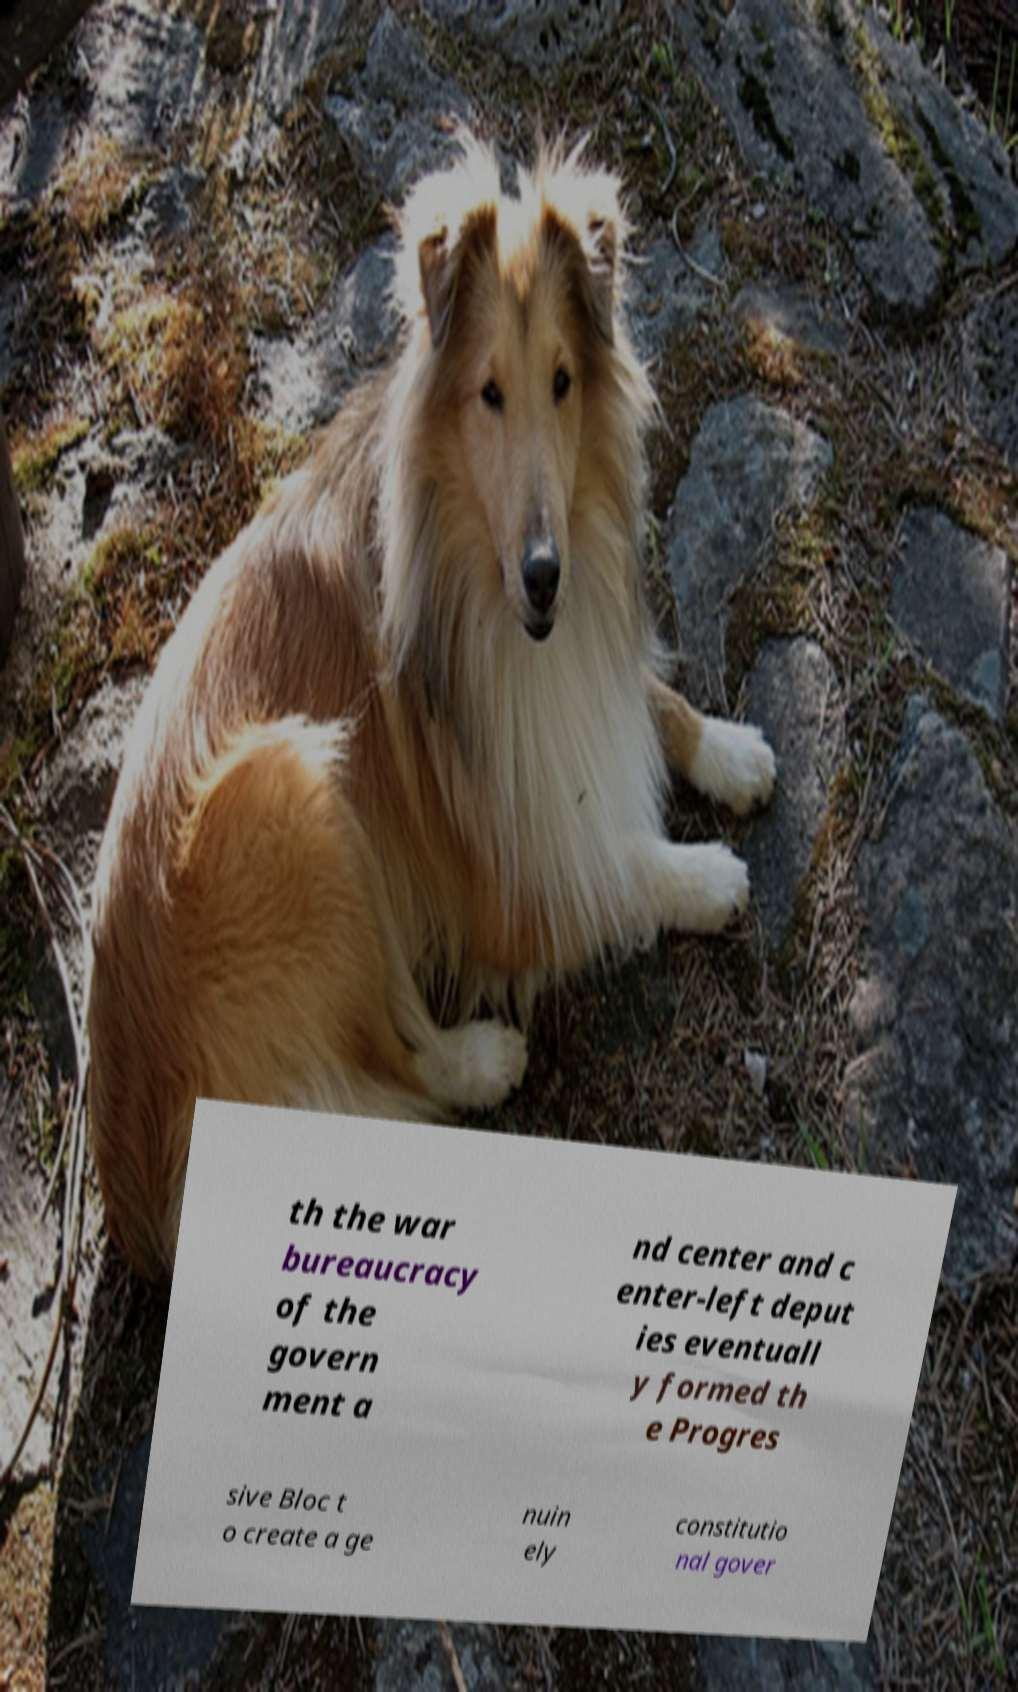Please read and relay the text visible in this image. What does it say? th the war bureaucracy of the govern ment a nd center and c enter-left deput ies eventuall y formed th e Progres sive Bloc t o create a ge nuin ely constitutio nal gover 